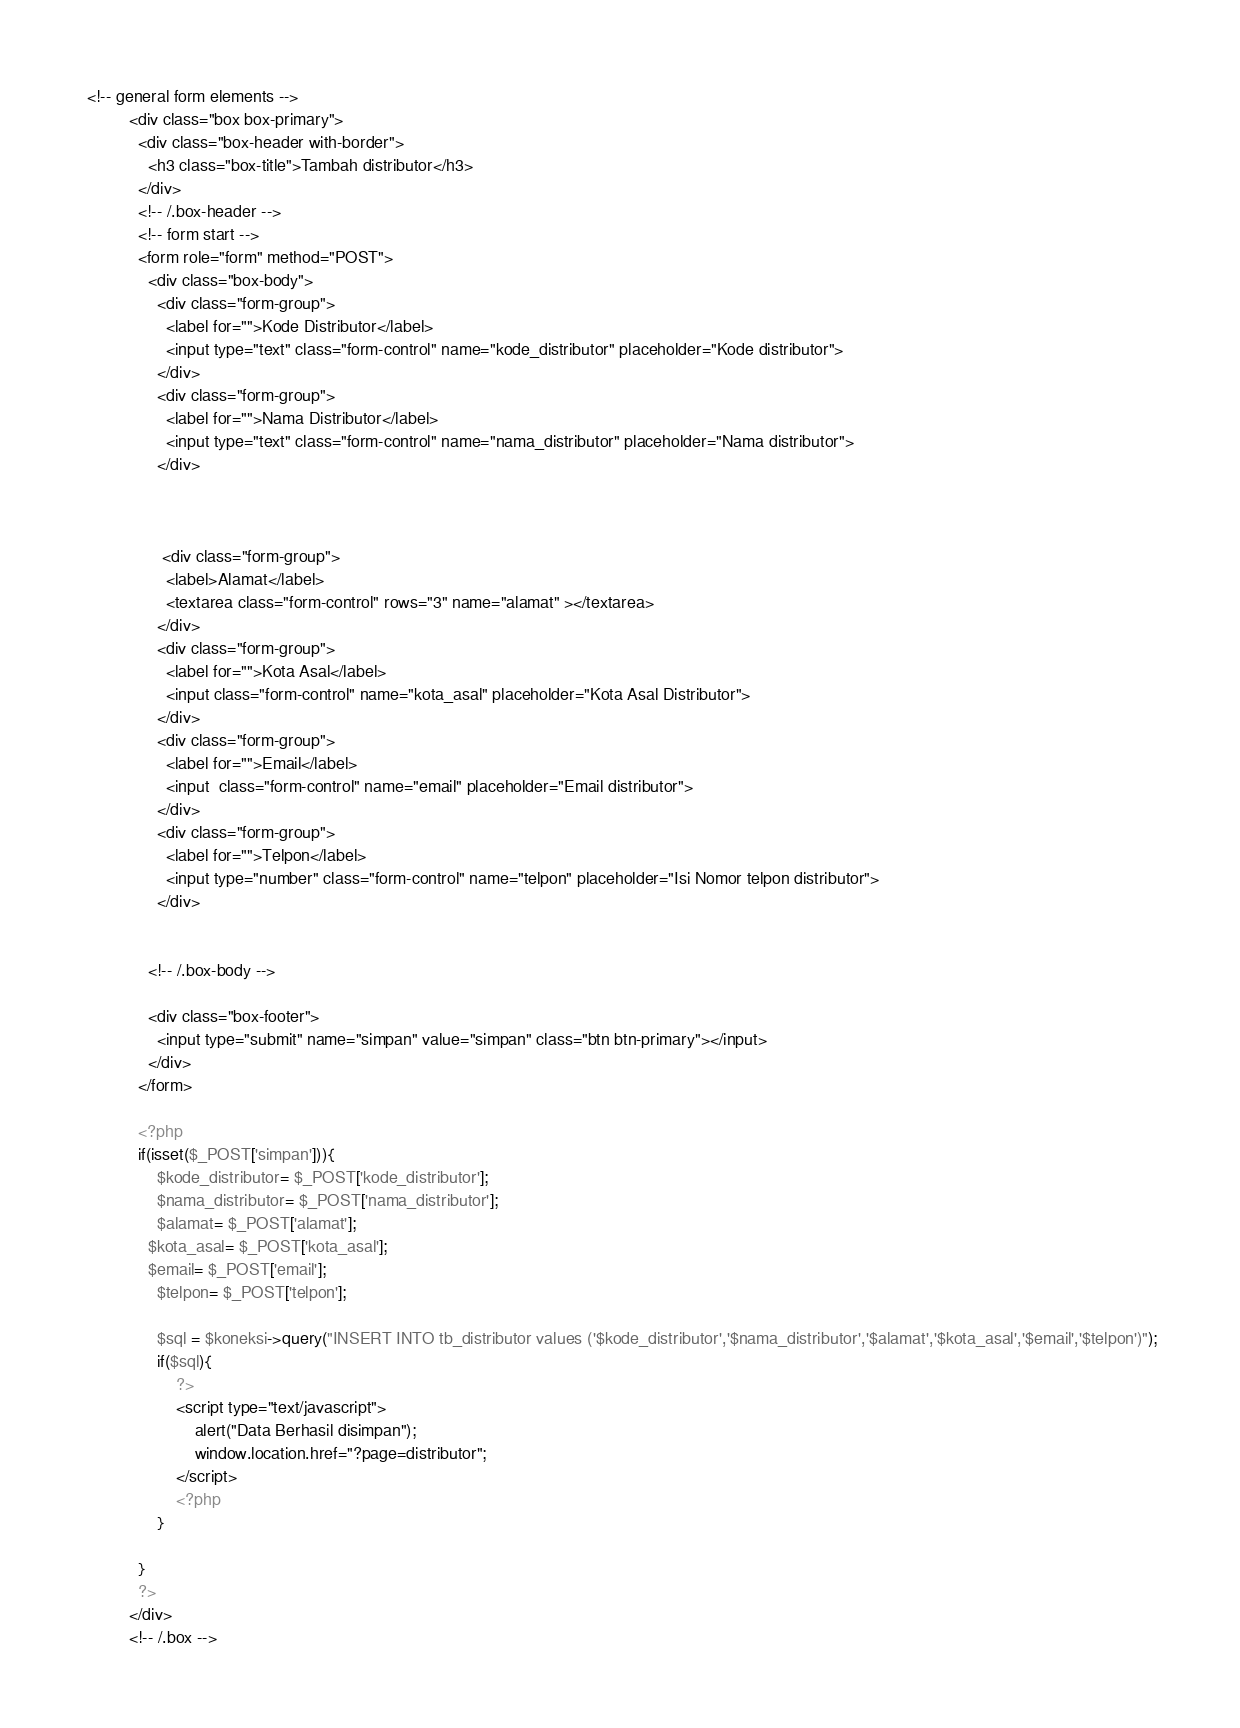Convert code to text. <code><loc_0><loc_0><loc_500><loc_500><_PHP_>
 <!-- general form elements -->
          <div class="box box-primary">
            <div class="box-header with-border">
              <h3 class="box-title">Tambah distributor</h3>
            </div>
            <!-- /.box-header -->
            <!-- form start -->
            <form role="form" method="POST">
              <div class="box-body">
                <div class="form-group">
                  <label for="">Kode Distributor</label>
                  <input type="text" class="form-control" name="kode_distributor" placeholder="Kode distributor">
                </div>
                <div class="form-group">
                  <label for="">Nama Distributor</label>
                  <input type="text" class="form-control" name="nama_distributor" placeholder="Nama distributor">
                </div>
           
               
                
                 <div class="form-group">
                  <label>Alamat</label>
                  <textarea class="form-control" rows="3" name="alamat" ></textarea>
                </div>
                <div class="form-group">
                  <label for="">Kota Asal</label>
                  <input class="form-control" name="kota_asal" placeholder="Kota Asal Distributor">
                </div>
                <div class="form-group">
                  <label for="">Email</label>
                  <input  class="form-control" name="email" placeholder="Email distributor">
                </div>
                <div class="form-group">
                  <label for="">Telpon</label>
                  <input type="number" class="form-control" name="telpon" placeholder="Isi Nomor telpon distributor">
                </div>
                 
               
              <!-- /.box-body -->

              <div class="box-footer">
                <input type="submit" name="simpan" value="simpan" class="btn btn-primary"></input>
              </div>
            </form>

            <?php
            if(isset($_POST['simpan'])){
            	$kode_distributor= $_POST['kode_distributor'];
            	$nama_distributor= $_POST['nama_distributor'];
            	$alamat= $_POST['alamat'];
              $kota_asal= $_POST['kota_asal'];
              $email= $_POST['email'];
            	$telpon= $_POST['telpon'];

            	$sql = $koneksi->query("INSERT INTO tb_distributor values ('$kode_distributor','$nama_distributor','$alamat','$kota_asal','$email','$telpon')");
 				if($sql){
 					?>
 					<script type="text/javascript">
 						alert("Data Berhasil disimpan");
 						window.location.href="?page=distributor";
 					</script>
 					<?php
 				}

            }
            ?>
          </div>
          <!-- /.box --></code> 